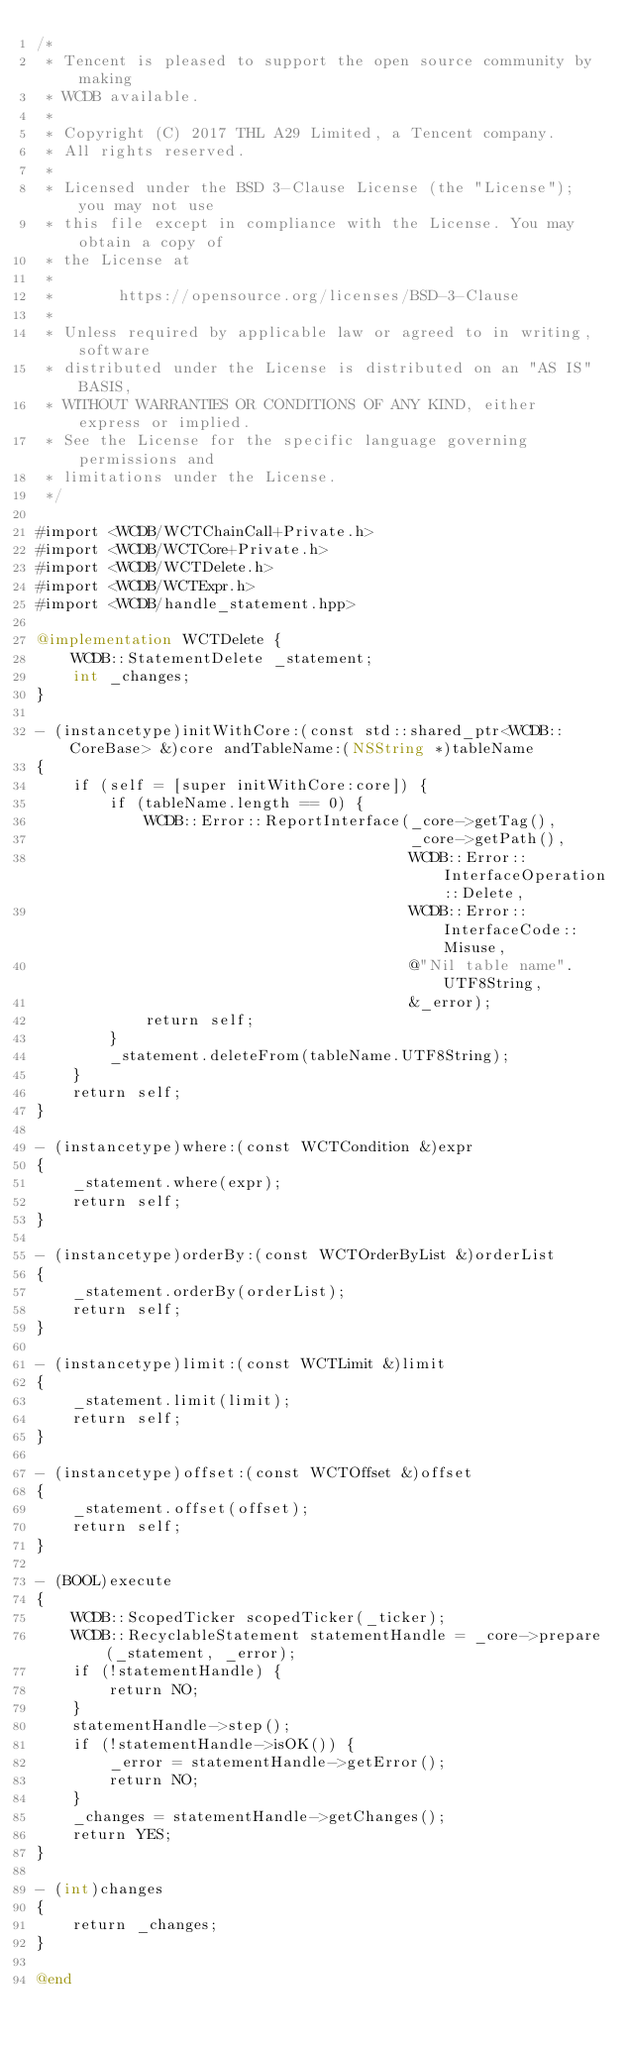Convert code to text. <code><loc_0><loc_0><loc_500><loc_500><_ObjectiveC_>/*
 * Tencent is pleased to support the open source community by making
 * WCDB available.
 *
 * Copyright (C) 2017 THL A29 Limited, a Tencent company.
 * All rights reserved.
 *
 * Licensed under the BSD 3-Clause License (the "License"); you may not use
 * this file except in compliance with the License. You may obtain a copy of
 * the License at
 *
 *       https://opensource.org/licenses/BSD-3-Clause
 *
 * Unless required by applicable law or agreed to in writing, software
 * distributed under the License is distributed on an "AS IS" BASIS,
 * WITHOUT WARRANTIES OR CONDITIONS OF ANY KIND, either express or implied.
 * See the License for the specific language governing permissions and
 * limitations under the License.
 */

#import <WCDB/WCTChainCall+Private.h>
#import <WCDB/WCTCore+Private.h>
#import <WCDB/WCTDelete.h>
#import <WCDB/WCTExpr.h>
#import <WCDB/handle_statement.hpp>

@implementation WCTDelete {
    WCDB::StatementDelete _statement;
    int _changes;
}

- (instancetype)initWithCore:(const std::shared_ptr<WCDB::CoreBase> &)core andTableName:(NSString *)tableName
{
    if (self = [super initWithCore:core]) {
        if (tableName.length == 0) {
            WCDB::Error::ReportInterface(_core->getTag(),
                                         _core->getPath(),
                                         WCDB::Error::InterfaceOperation::Delete,
                                         WCDB::Error::InterfaceCode::Misuse,
                                         @"Nil table name".UTF8String,
                                         &_error);
            return self;
        }
        _statement.deleteFrom(tableName.UTF8String);
    }
    return self;
}

- (instancetype)where:(const WCTCondition &)expr
{
    _statement.where(expr);
    return self;
}

- (instancetype)orderBy:(const WCTOrderByList &)orderList
{
    _statement.orderBy(orderList);
    return self;
}

- (instancetype)limit:(const WCTLimit &)limit
{
    _statement.limit(limit);
    return self;
}

- (instancetype)offset:(const WCTOffset &)offset
{
    _statement.offset(offset);
    return self;
}

- (BOOL)execute
{
    WCDB::ScopedTicker scopedTicker(_ticker);
    WCDB::RecyclableStatement statementHandle = _core->prepare(_statement, _error);
    if (!statementHandle) {
        return NO;
    }
    statementHandle->step();
    if (!statementHandle->isOK()) {
        _error = statementHandle->getError();
        return NO;
    }
    _changes = statementHandle->getChanges();
    return YES;
}

- (int)changes
{
    return _changes;
}

@end
</code> 